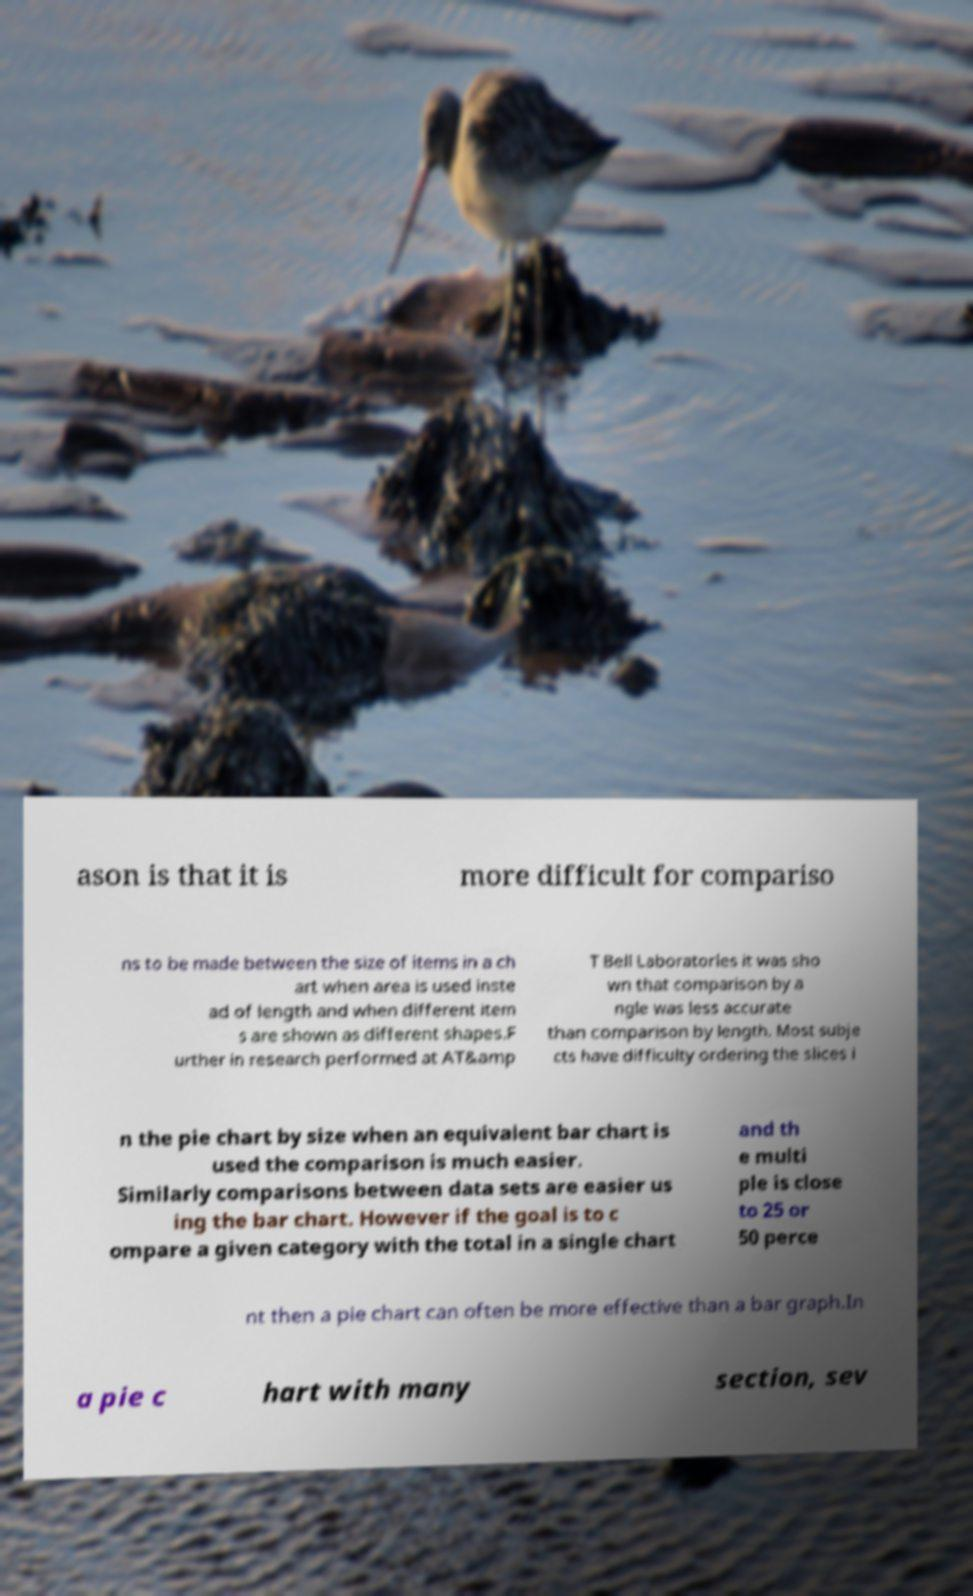Could you assist in decoding the text presented in this image and type it out clearly? ason is that it is more difficult for compariso ns to be made between the size of items in a ch art when area is used inste ad of length and when different item s are shown as different shapes.F urther in research performed at AT&amp T Bell Laboratories it was sho wn that comparison by a ngle was less accurate than comparison by length. Most subje cts have difficulty ordering the slices i n the pie chart by size when an equivalent bar chart is used the comparison is much easier. Similarly comparisons between data sets are easier us ing the bar chart. However if the goal is to c ompare a given category with the total in a single chart and th e multi ple is close to 25 or 50 perce nt then a pie chart can often be more effective than a bar graph.In a pie c hart with many section, sev 